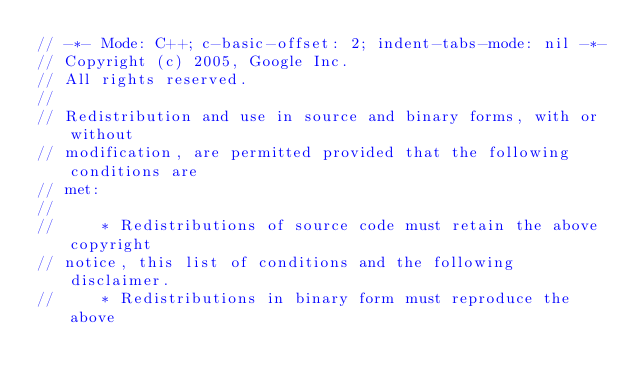<code> <loc_0><loc_0><loc_500><loc_500><_C++_>// -*- Mode: C++; c-basic-offset: 2; indent-tabs-mode: nil -*-
// Copyright (c) 2005, Google Inc.
// All rights reserved.
//
// Redistribution and use in source and binary forms, with or without
// modification, are permitted provided that the following conditions are
// met:
//
//     * Redistributions of source code must retain the above copyright
// notice, this list of conditions and the following disclaimer.
//     * Redistributions in binary form must reproduce the above</code> 